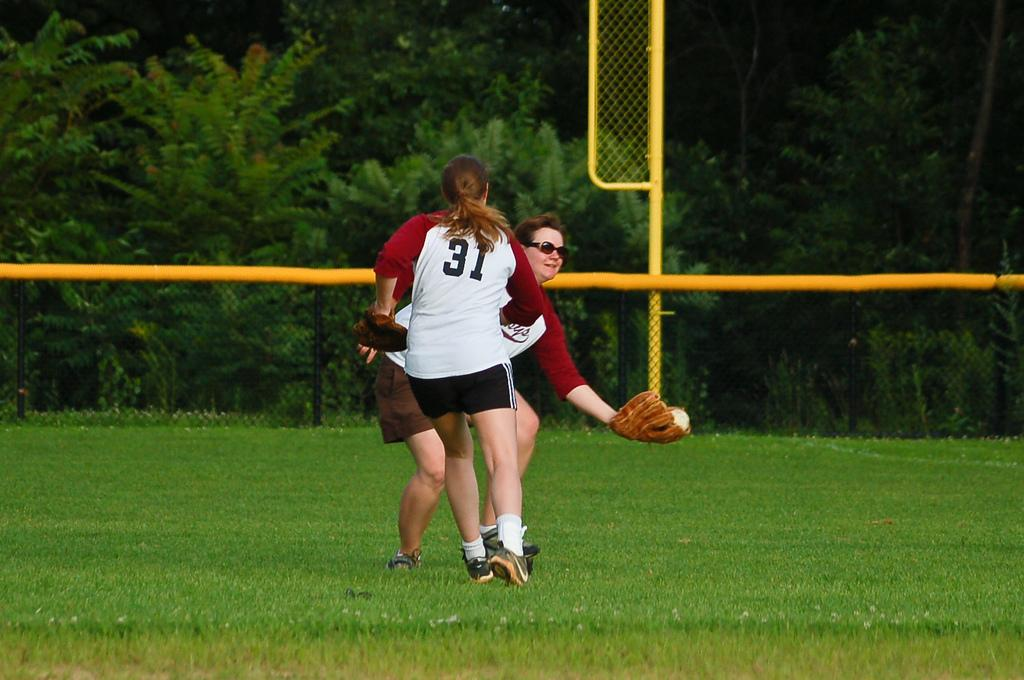<image>
Present a compact description of the photo's key features. player number 31 running toward another player catching a softball 